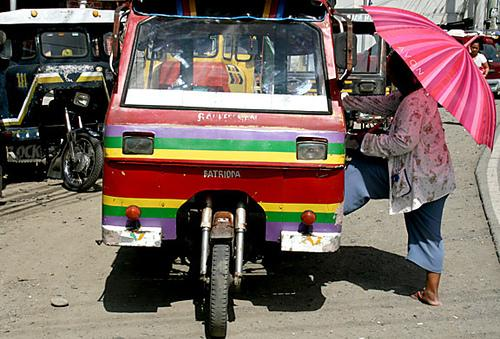What color is at the bottom front of the vehicle in the foreground? purple 